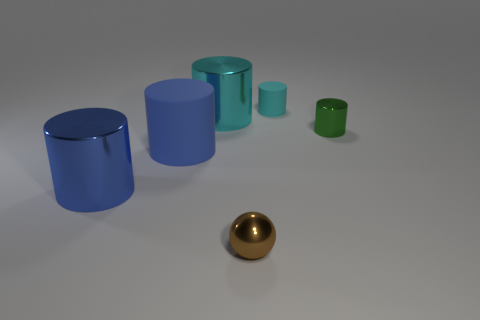What number of other objects are the same shape as the tiny green object?
Keep it short and to the point. 4. There is a tiny brown metal ball; what number of brown spheres are left of it?
Ensure brevity in your answer.  0. There is a cylinder that is both right of the blue shiny cylinder and in front of the tiny green thing; how big is it?
Your answer should be compact. Large. Is there a large rubber cylinder?
Your answer should be compact. Yes. How many other things are there of the same size as the blue metallic cylinder?
Your answer should be compact. 2. Is the color of the matte cylinder that is in front of the big cyan metal cylinder the same as the metal cylinder in front of the green metallic thing?
Ensure brevity in your answer.  Yes. What size is the blue rubber thing that is the same shape as the small green metal object?
Your answer should be compact. Large. Does the cyan cylinder right of the brown metallic ball have the same material as the tiny thing that is in front of the green shiny thing?
Make the answer very short. No. What number of metallic objects are either cyan things or large cylinders?
Ensure brevity in your answer.  2. There is a cyan object left of the small metal thing to the left of the cyan cylinder behind the big cyan object; what is it made of?
Provide a succinct answer. Metal. 